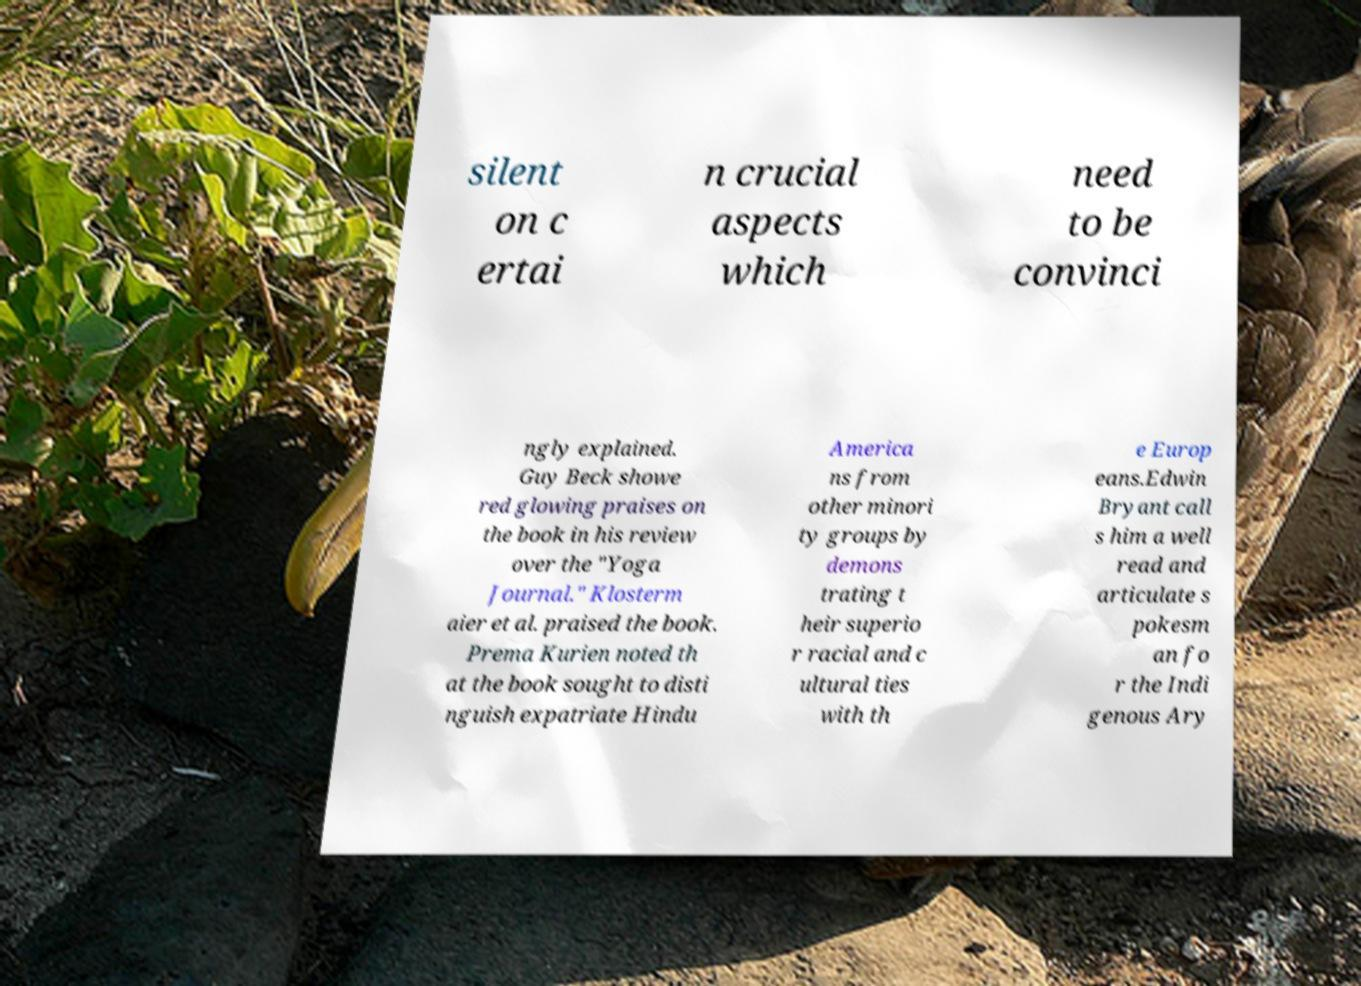Could you assist in decoding the text presented in this image and type it out clearly? silent on c ertai n crucial aspects which need to be convinci ngly explained. Guy Beck showe red glowing praises on the book in his review over the "Yoga Journal." Klosterm aier et al. praised the book. Prema Kurien noted th at the book sought to disti nguish expatriate Hindu America ns from other minori ty groups by demons trating t heir superio r racial and c ultural ties with th e Europ eans.Edwin Bryant call s him a well read and articulate s pokesm an fo r the Indi genous Ary 